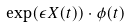<formula> <loc_0><loc_0><loc_500><loc_500>\exp ( \epsilon X ( t ) ) \cdot \phi ( t )</formula> 